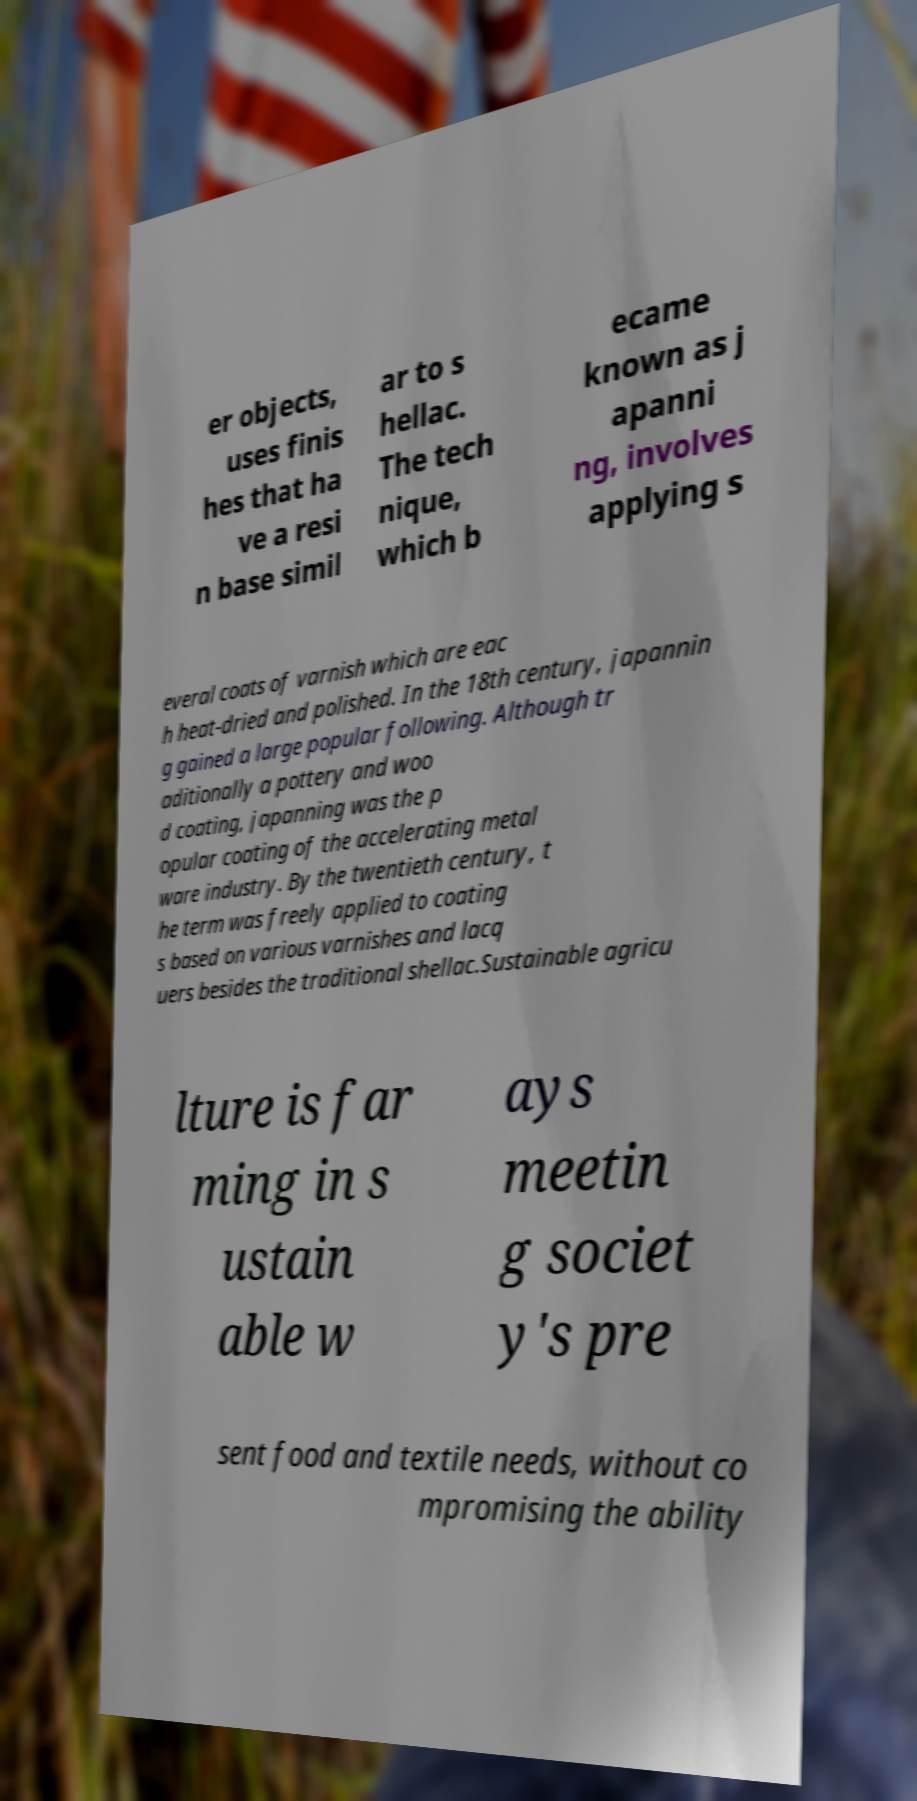Could you assist in decoding the text presented in this image and type it out clearly? er objects, uses finis hes that ha ve a resi n base simil ar to s hellac. The tech nique, which b ecame known as j apanni ng, involves applying s everal coats of varnish which are eac h heat-dried and polished. In the 18th century, japannin g gained a large popular following. Although tr aditionally a pottery and woo d coating, japanning was the p opular coating of the accelerating metal ware industry. By the twentieth century, t he term was freely applied to coating s based on various varnishes and lacq uers besides the traditional shellac.Sustainable agricu lture is far ming in s ustain able w ays meetin g societ y's pre sent food and textile needs, without co mpromising the ability 